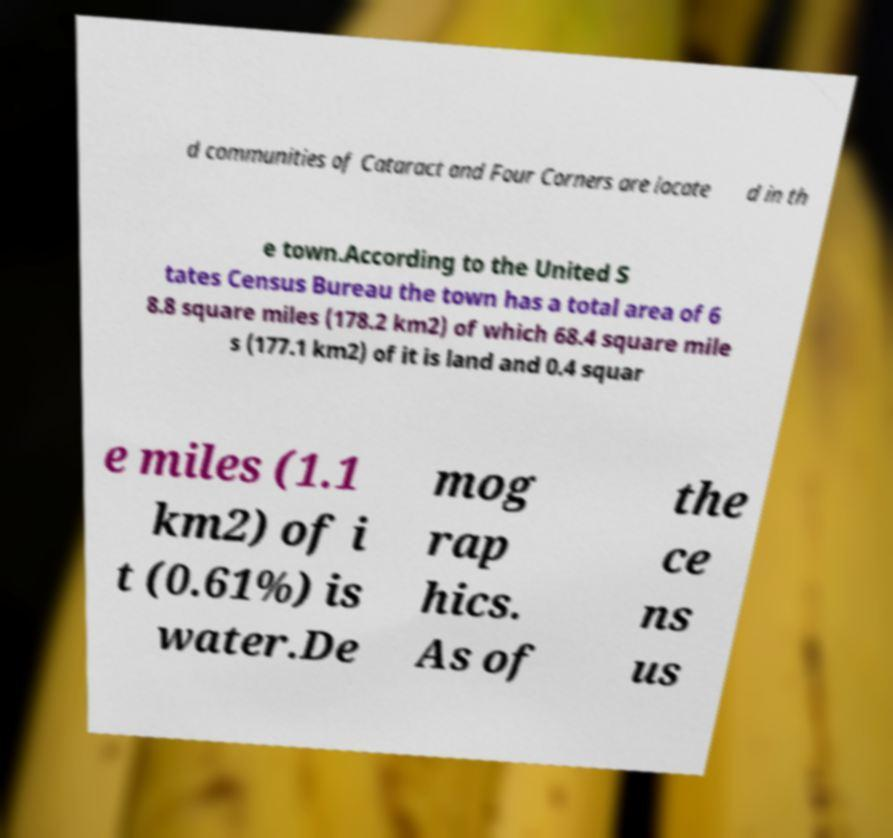Can you read and provide the text displayed in the image?This photo seems to have some interesting text. Can you extract and type it out for me? d communities of Cataract and Four Corners are locate d in th e town.According to the United S tates Census Bureau the town has a total area of 6 8.8 square miles (178.2 km2) of which 68.4 square mile s (177.1 km2) of it is land and 0.4 squar e miles (1.1 km2) of i t (0.61%) is water.De mog rap hics. As of the ce ns us 